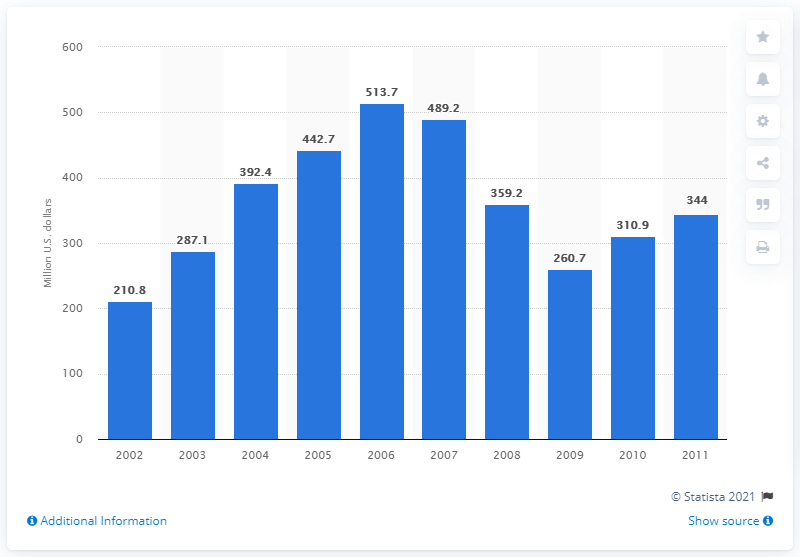Highlight a few significant elements in this photo. In 2009, the value of U.S. product shipments of women's and children's handbags and purses was $260.7 million. 